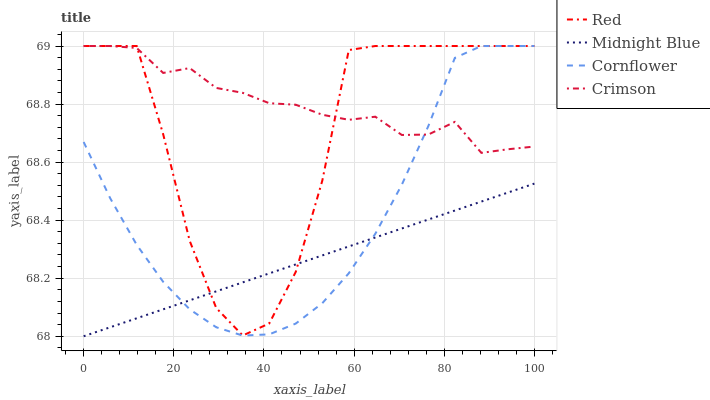Does Midnight Blue have the minimum area under the curve?
Answer yes or no. Yes. Does Crimson have the maximum area under the curve?
Answer yes or no. Yes. Does Cornflower have the minimum area under the curve?
Answer yes or no. No. Does Cornflower have the maximum area under the curve?
Answer yes or no. No. Is Midnight Blue the smoothest?
Answer yes or no. Yes. Is Red the roughest?
Answer yes or no. Yes. Is Cornflower the smoothest?
Answer yes or no. No. Is Cornflower the roughest?
Answer yes or no. No. Does Cornflower have the lowest value?
Answer yes or no. No. Does Red have the highest value?
Answer yes or no. Yes. Does Midnight Blue have the highest value?
Answer yes or no. No. Is Midnight Blue less than Crimson?
Answer yes or no. Yes. Is Crimson greater than Midnight Blue?
Answer yes or no. Yes. Does Midnight Blue intersect Red?
Answer yes or no. Yes. Is Midnight Blue less than Red?
Answer yes or no. No. Is Midnight Blue greater than Red?
Answer yes or no. No. Does Midnight Blue intersect Crimson?
Answer yes or no. No. 